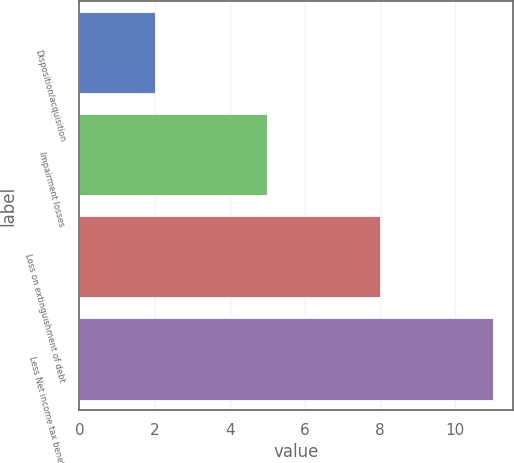Convert chart to OTSL. <chart><loc_0><loc_0><loc_500><loc_500><bar_chart><fcel>Disposition/acquisition<fcel>Impairment losses<fcel>Loss on extinguishment of debt<fcel>Less Net income tax benefit<nl><fcel>2<fcel>5<fcel>8<fcel>11<nl></chart> 